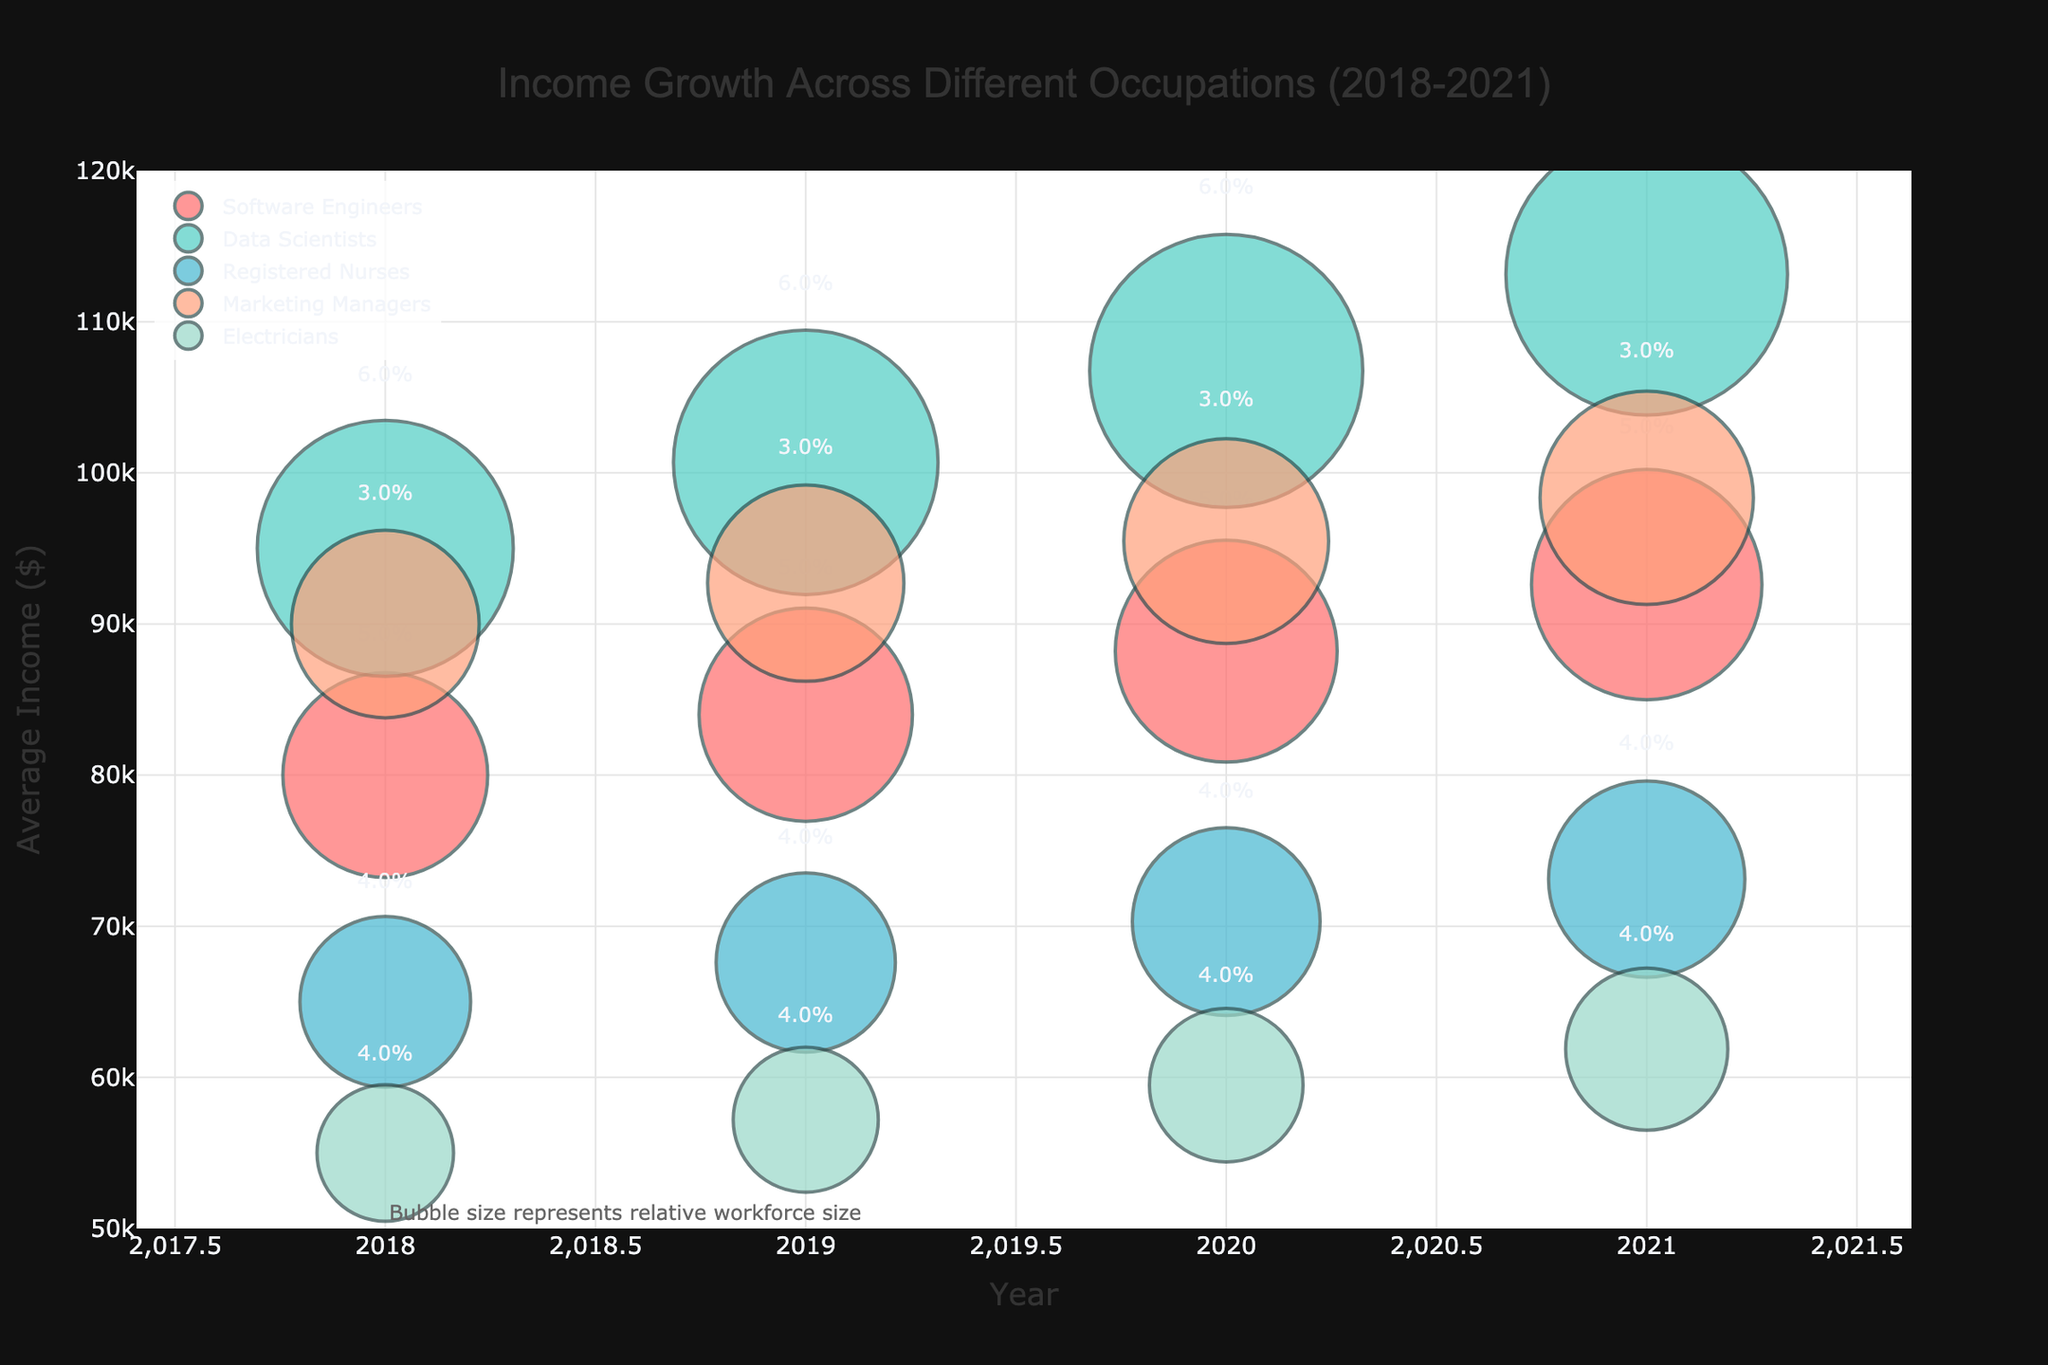What is the title of the chart? The title of the chart is displayed prominently at the top, centered and bolded, which says, "Income Growth Across Different Occupations (2018-2021)."
Answer: Income Growth Across Different Occupations (2018-2021) Which occupation had the highest average income in 2021? By looking at the highest point on the y-axis in 2021, the "Data Scientists" occupation reaches approximately $113,146.
Answer: Data Scientists How does the income growth rate compare between Software Engineers and Data Scientists? The growth rate information is shown above the bubbles. Software Engineers have a growth rate of 5%, while Data Scientists have a slightly higher growth rate of 6%.
Answer: Data Scientists have a higher growth rate Which job has the smallest workforce size relative to others in 2018? Bubble size represents workforce size. The smallest bubble in 2018 belongs to "Electricians" with a bubble size of 80.
Answer: Electricians What is the general trend for the average income of Registered Nurses from 2018 to 2021? Following the trend line for "Registered Nurses", the average income increases every year, starting from $65,000 in 2018 to about $73,116 in 2021.
Answer: Increasing trend How many occupations are represented in the chart? Occupations are represented by different colors and names in the legend. Counting them shows five distinct occupations.
Answer: Five Which occupation shows the least income growth rate and what is that rate? Checking above each bubble, "Marketing Managers" have the smallest growth rate, consistently at 3% each year from 2018 to 2021.
Answer: Marketing Managers, 3% Compare the workforce size growth of Electricians and Registered Nurses from 2018 to 2021. The text annotation mentions that bubble size indicates workforce size. Both occupations' bubble sizes increase. Electricians grow from 80 to 95, while Registered Nurses grow from 100 to 115. So, Electricians grow by 15, and Registered Nurses by 15.
Answer: They grow by equal amounts During which year did Software Engineers experience an average income closest to $90,000? Checking the plotted points for Software Engineers, their income in 2020 at approximately $88,200 is the closest to $90,000.
Answer: 2020 What trend is observed in the bubble sizes of Data Scientists from 2018 to 2021? Observing the bubbles for Data Scientists shows that the bubble sizes increase consistently from 150 in 2018 to 165 in 2021, indicating larger workforce size over these years.
Answer: Increasing trend 